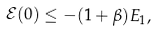Convert formula to latex. <formula><loc_0><loc_0><loc_500><loc_500>\mathcal { E } ( 0 ) \leq - ( 1 + \beta ) E _ { 1 } ,</formula> 